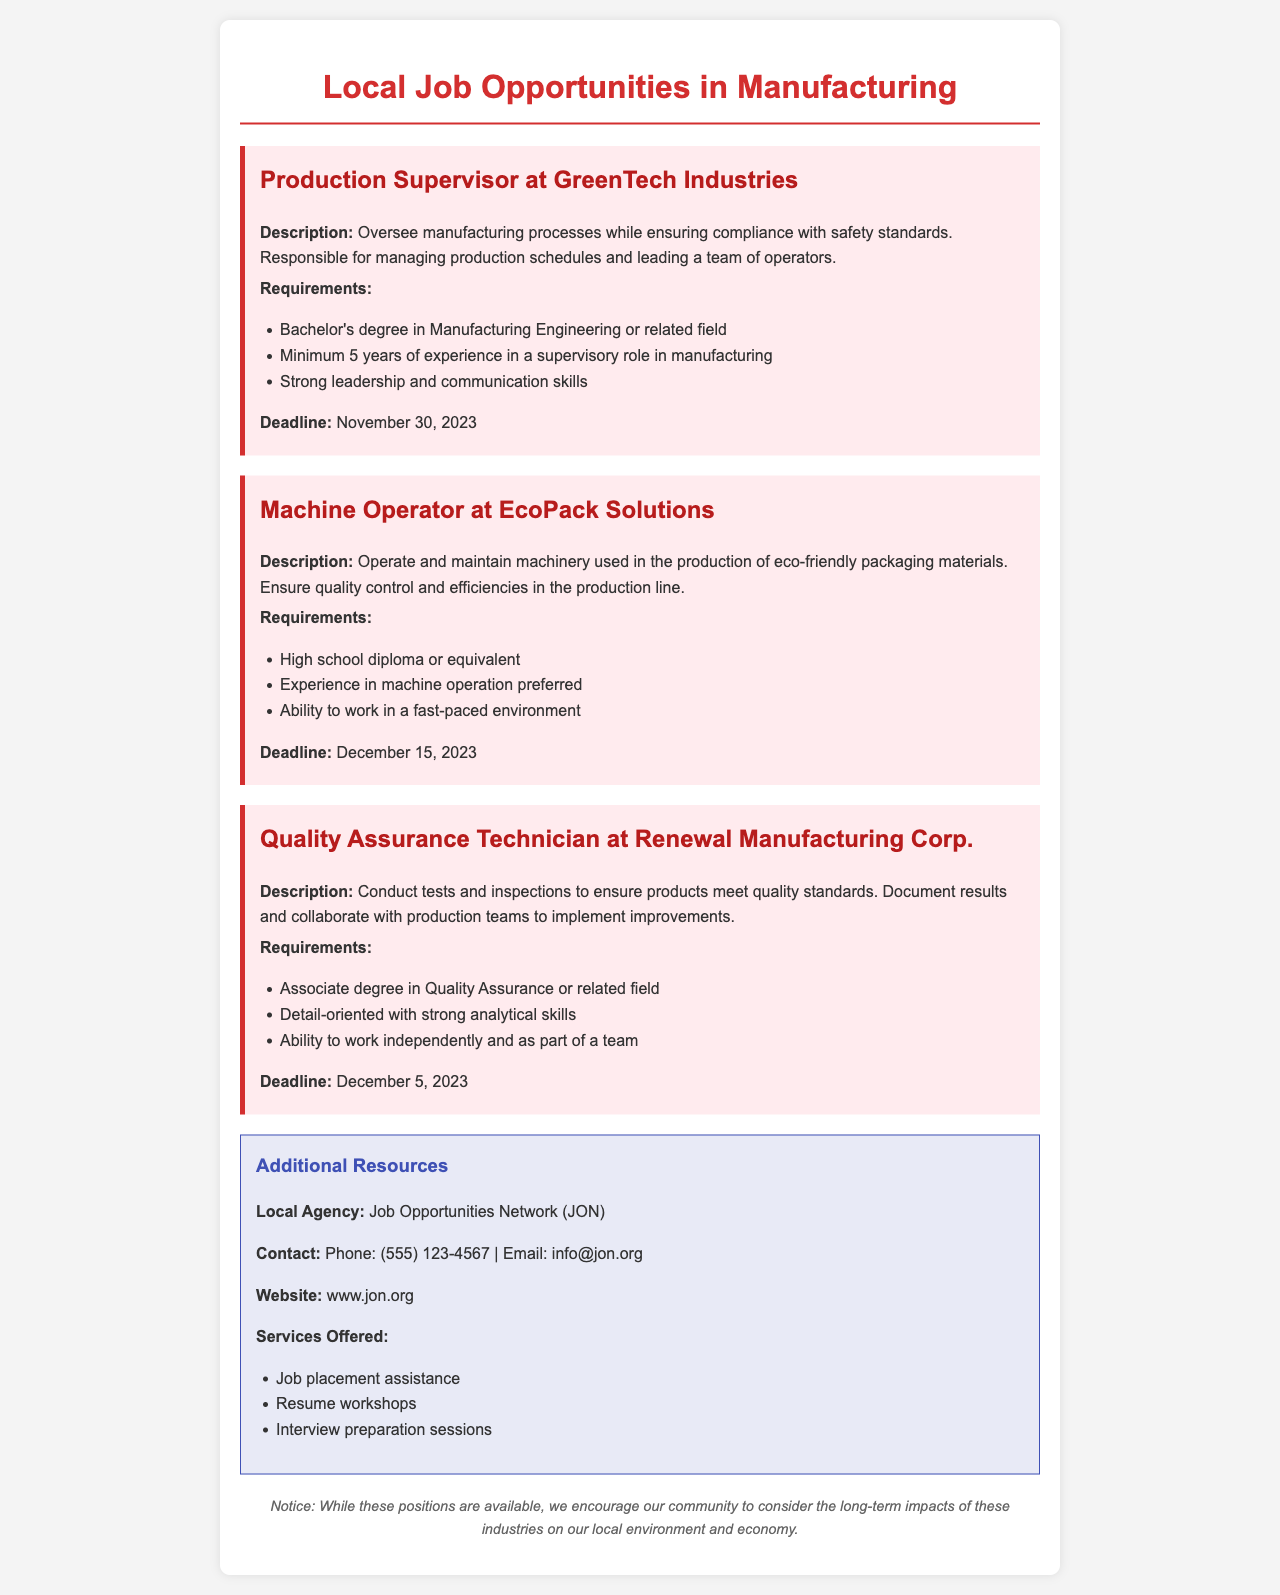What is the title of the document? The title of the document indicates its content and is stated clearly at the top as "Local Job Opportunities in Manufacturing."
Answer: Local Job Opportunities in Manufacturing Who is the employer for the Machine Operator position? This position is specified under the company name which is mentioned in the document.
Answer: EcoPack Solutions What is the deadline for the Quality Assurance Technician application? The document lists specific deadlines for each job posting directly associated with each position.
Answer: December 5, 2023 How many years of experience are required for the Production Supervisor role? The requirements for this role list a specific number of years needed for the candidates.
Answer: Minimum 5 years What is one of the services offered by the Job Opportunities Network? The document enumerates services provided by JON, making it clear what assistance can be expected.
Answer: Job placement assistance What educational background is needed for the Machine Operator position? The document specifies the educational requirements for this job position distinctly.
Answer: High school diploma or equivalent What is the main focus of EcoPack Solutions? Understanding the objectives of job roles can help assess the impact on the community's environment.
Answer: Production of eco-friendly packaging materials Which organization is mentioned as a local resource for job seekers? The document provides the name of an organization that helps connect individuals with job opportunities.
Answer: Job Opportunities Network (JON) 